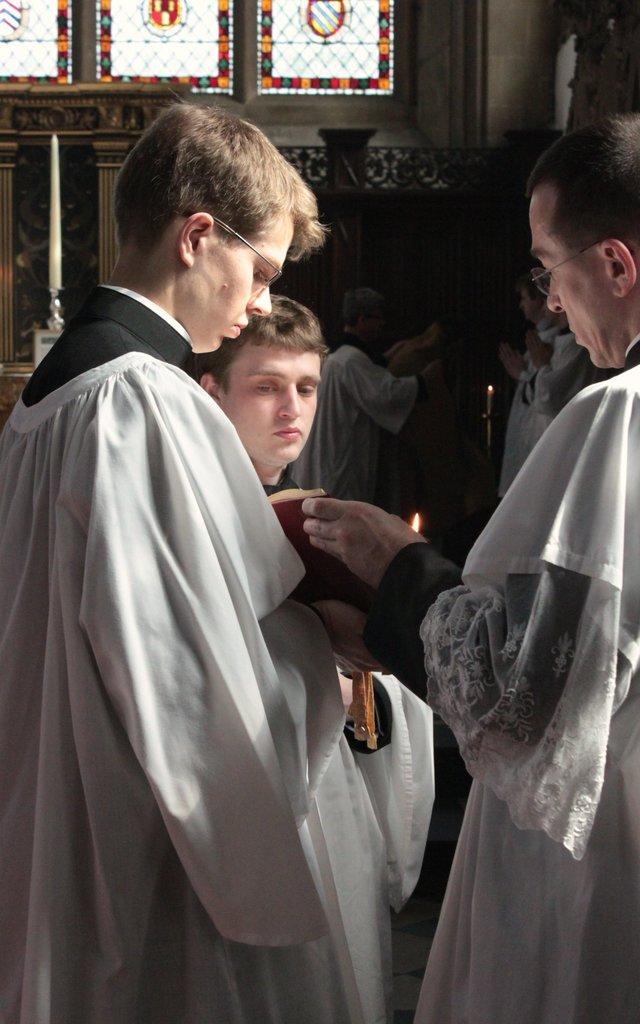How many people are in the image? There is a group of persons standing in the image. What can be seen in the background of the image? There are windows and a wall in the background of the image. Can you describe the color of any object in the image? There is an object that is black in color in the image. Can you tell me how many wrens are perched on the wall in the image? There are no wrens present in the image; it only features a group of persons and a wall in the background. 